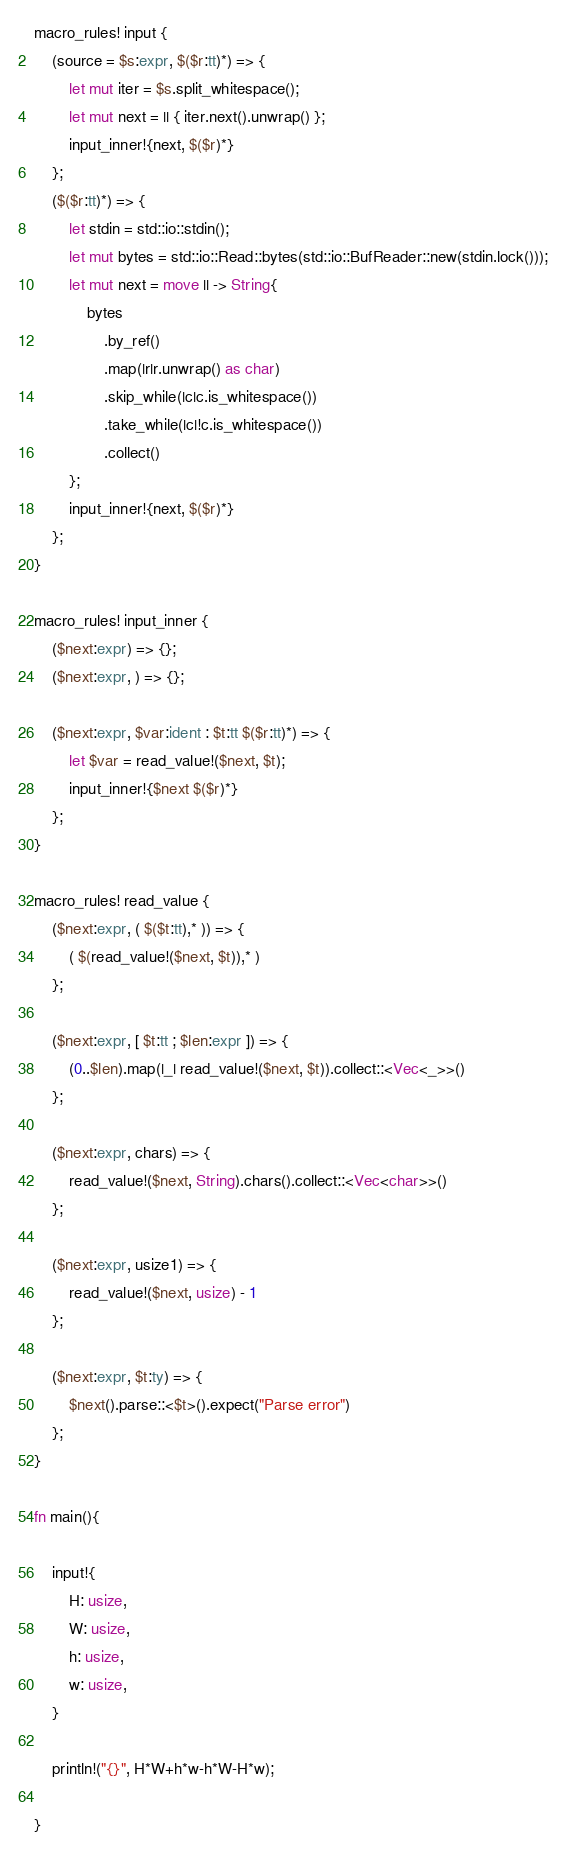Convert code to text. <code><loc_0><loc_0><loc_500><loc_500><_Rust_>macro_rules! input {
    (source = $s:expr, $($r:tt)*) => {
        let mut iter = $s.split_whitespace();
        let mut next = || { iter.next().unwrap() };
        input_inner!{next, $($r)*}
    };
    ($($r:tt)*) => {
        let stdin = std::io::stdin();
        let mut bytes = std::io::Read::bytes(std::io::BufReader::new(stdin.lock()));
        let mut next = move || -> String{
            bytes
                .by_ref()
                .map(|r|r.unwrap() as char)
                .skip_while(|c|c.is_whitespace())
                .take_while(|c|!c.is_whitespace())
                .collect()
        };
        input_inner!{next, $($r)*}
    };
}

macro_rules! input_inner {
    ($next:expr) => {};
    ($next:expr, ) => {};

    ($next:expr, $var:ident : $t:tt $($r:tt)*) => {
        let $var = read_value!($next, $t);
        input_inner!{$next $($r)*}
    };
}

macro_rules! read_value {
    ($next:expr, ( $($t:tt),* )) => {
        ( $(read_value!($next, $t)),* )
    };

    ($next:expr, [ $t:tt ; $len:expr ]) => {
        (0..$len).map(|_| read_value!($next, $t)).collect::<Vec<_>>()
    };

    ($next:expr, chars) => {
        read_value!($next, String).chars().collect::<Vec<char>>()
    };

    ($next:expr, usize1) => {
        read_value!($next, usize) - 1
    };

    ($next:expr, $t:ty) => {
        $next().parse::<$t>().expect("Parse error")
    };
}

fn main(){

    input!{
        H: usize,
        W: usize,
        h: usize,
        w: usize,
    }

    println!("{}", H*W+h*w-h*W-H*w);

}</code> 